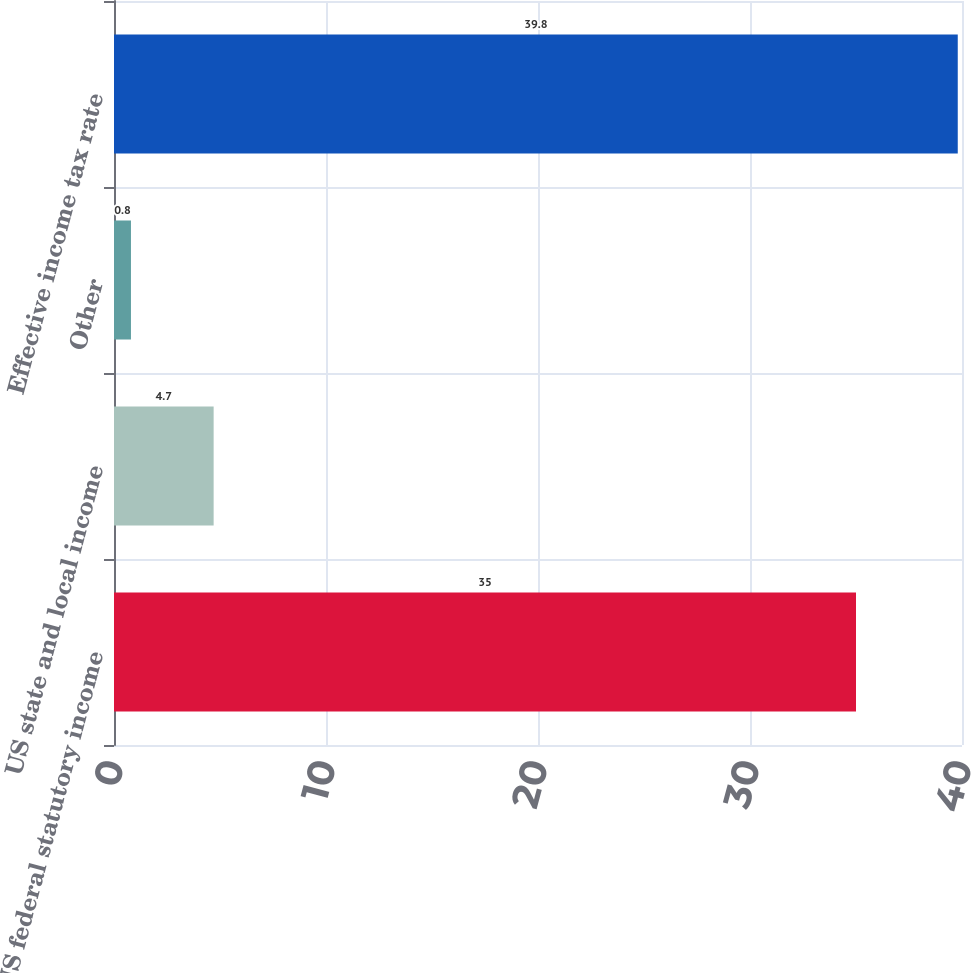Convert chart. <chart><loc_0><loc_0><loc_500><loc_500><bar_chart><fcel>US federal statutory income<fcel>US state and local income<fcel>Other<fcel>Effective income tax rate<nl><fcel>35<fcel>4.7<fcel>0.8<fcel>39.8<nl></chart> 